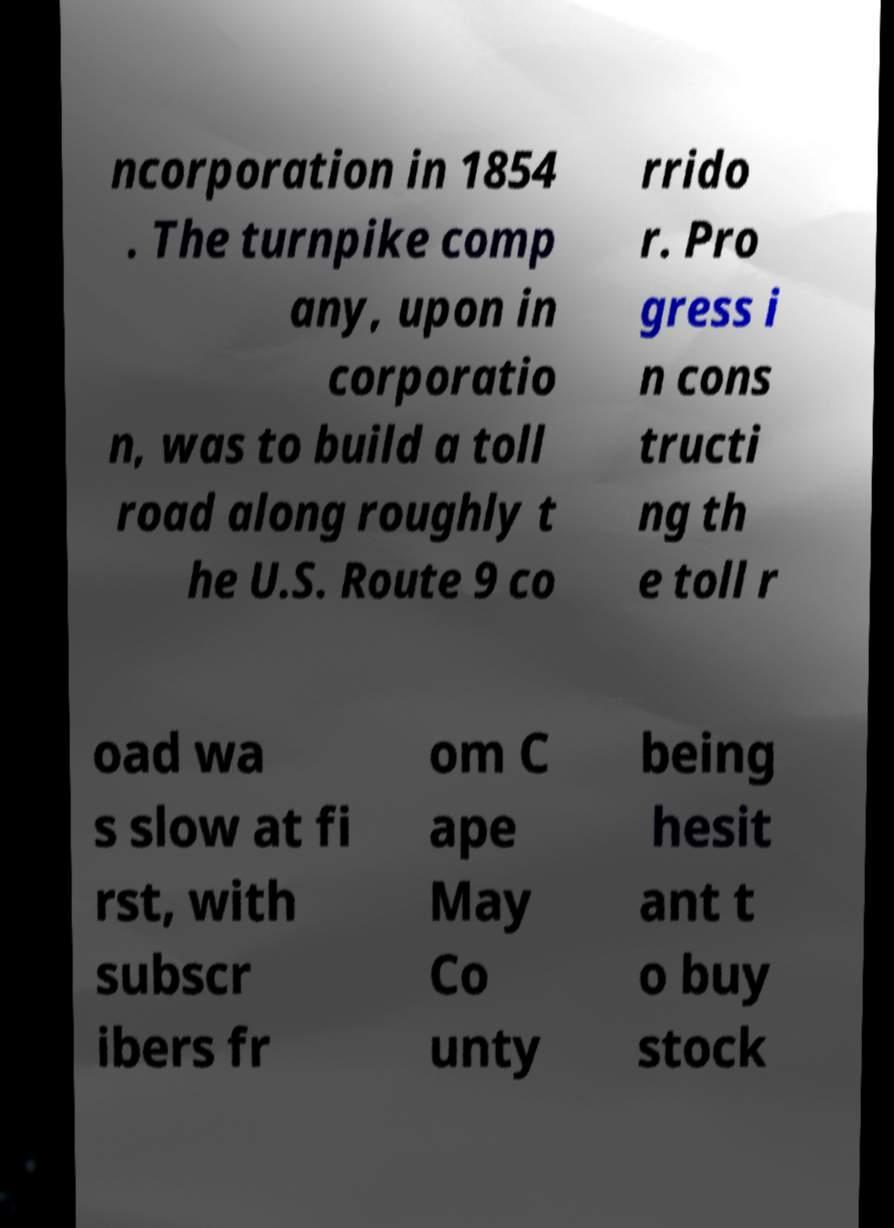What messages or text are displayed in this image? I need them in a readable, typed format. ncorporation in 1854 . The turnpike comp any, upon in corporatio n, was to build a toll road along roughly t he U.S. Route 9 co rrido r. Pro gress i n cons tructi ng th e toll r oad wa s slow at fi rst, with subscr ibers fr om C ape May Co unty being hesit ant t o buy stock 